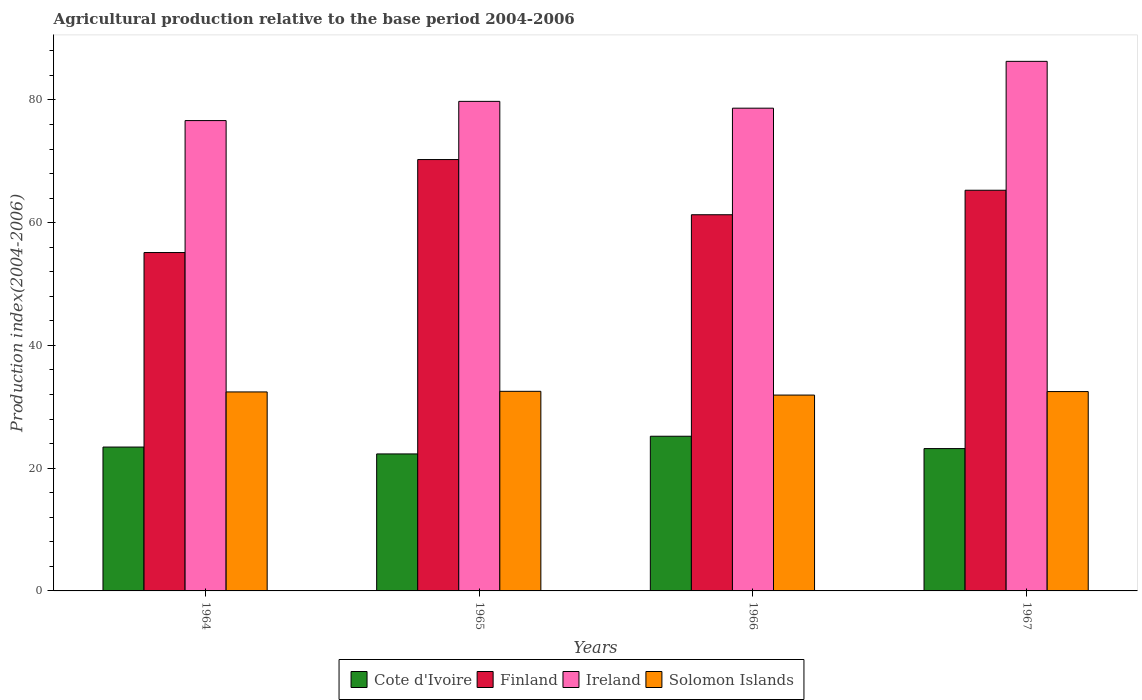How many different coloured bars are there?
Provide a succinct answer. 4. How many groups of bars are there?
Your answer should be very brief. 4. Are the number of bars on each tick of the X-axis equal?
Offer a terse response. Yes. How many bars are there on the 2nd tick from the right?
Your answer should be very brief. 4. What is the label of the 2nd group of bars from the left?
Offer a terse response. 1965. What is the agricultural production index in Ireland in 1964?
Provide a succinct answer. 76.63. Across all years, what is the maximum agricultural production index in Cote d'Ivoire?
Your answer should be very brief. 25.2. Across all years, what is the minimum agricultural production index in Cote d'Ivoire?
Provide a short and direct response. 22.32. In which year was the agricultural production index in Ireland maximum?
Your answer should be compact. 1967. In which year was the agricultural production index in Solomon Islands minimum?
Keep it short and to the point. 1966. What is the total agricultural production index in Solomon Islands in the graph?
Offer a very short reply. 129.33. What is the difference between the agricultural production index in Finland in 1964 and that in 1966?
Your answer should be compact. -6.16. What is the difference between the agricultural production index in Finland in 1964 and the agricultural production index in Solomon Islands in 1967?
Ensure brevity in your answer.  22.65. What is the average agricultural production index in Cote d'Ivoire per year?
Provide a short and direct response. 23.54. In the year 1967, what is the difference between the agricultural production index in Finland and agricultural production index in Solomon Islands?
Keep it short and to the point. 32.8. In how many years, is the agricultural production index in Ireland greater than 48?
Give a very brief answer. 4. What is the ratio of the agricultural production index in Solomon Islands in 1964 to that in 1966?
Provide a short and direct response. 1.02. Is the agricultural production index in Finland in 1965 less than that in 1966?
Provide a succinct answer. No. Is the difference between the agricultural production index in Finland in 1964 and 1965 greater than the difference between the agricultural production index in Solomon Islands in 1964 and 1965?
Provide a short and direct response. No. What is the difference between the highest and the second highest agricultural production index in Solomon Islands?
Offer a very short reply. 0.04. What is the difference between the highest and the lowest agricultural production index in Cote d'Ivoire?
Provide a short and direct response. 2.88. Is the sum of the agricultural production index in Finland in 1965 and 1966 greater than the maximum agricultural production index in Ireland across all years?
Offer a terse response. Yes. What does the 2nd bar from the left in 1967 represents?
Offer a terse response. Finland. What does the 2nd bar from the right in 1965 represents?
Keep it short and to the point. Ireland. Are all the bars in the graph horizontal?
Provide a short and direct response. No. How many years are there in the graph?
Make the answer very short. 4. Does the graph contain any zero values?
Offer a terse response. No. How many legend labels are there?
Your answer should be very brief. 4. How are the legend labels stacked?
Keep it short and to the point. Horizontal. What is the title of the graph?
Your response must be concise. Agricultural production relative to the base period 2004-2006. What is the label or title of the X-axis?
Provide a short and direct response. Years. What is the label or title of the Y-axis?
Provide a short and direct response. Production index(2004-2006). What is the Production index(2004-2006) in Cote d'Ivoire in 1964?
Keep it short and to the point. 23.44. What is the Production index(2004-2006) of Finland in 1964?
Give a very brief answer. 55.13. What is the Production index(2004-2006) of Ireland in 1964?
Your response must be concise. 76.63. What is the Production index(2004-2006) of Solomon Islands in 1964?
Provide a short and direct response. 32.42. What is the Production index(2004-2006) in Cote d'Ivoire in 1965?
Your answer should be very brief. 22.32. What is the Production index(2004-2006) of Finland in 1965?
Your answer should be compact. 70.28. What is the Production index(2004-2006) in Ireland in 1965?
Your answer should be compact. 79.76. What is the Production index(2004-2006) in Solomon Islands in 1965?
Ensure brevity in your answer.  32.52. What is the Production index(2004-2006) of Cote d'Ivoire in 1966?
Ensure brevity in your answer.  25.2. What is the Production index(2004-2006) of Finland in 1966?
Provide a short and direct response. 61.29. What is the Production index(2004-2006) in Ireland in 1966?
Provide a short and direct response. 78.65. What is the Production index(2004-2006) of Solomon Islands in 1966?
Provide a succinct answer. 31.91. What is the Production index(2004-2006) of Cote d'Ivoire in 1967?
Give a very brief answer. 23.19. What is the Production index(2004-2006) of Finland in 1967?
Provide a succinct answer. 65.28. What is the Production index(2004-2006) in Ireland in 1967?
Offer a very short reply. 86.28. What is the Production index(2004-2006) in Solomon Islands in 1967?
Give a very brief answer. 32.48. Across all years, what is the maximum Production index(2004-2006) in Cote d'Ivoire?
Offer a terse response. 25.2. Across all years, what is the maximum Production index(2004-2006) of Finland?
Your response must be concise. 70.28. Across all years, what is the maximum Production index(2004-2006) of Ireland?
Offer a terse response. 86.28. Across all years, what is the maximum Production index(2004-2006) in Solomon Islands?
Keep it short and to the point. 32.52. Across all years, what is the minimum Production index(2004-2006) of Cote d'Ivoire?
Give a very brief answer. 22.32. Across all years, what is the minimum Production index(2004-2006) of Finland?
Offer a terse response. 55.13. Across all years, what is the minimum Production index(2004-2006) of Ireland?
Your response must be concise. 76.63. Across all years, what is the minimum Production index(2004-2006) in Solomon Islands?
Provide a short and direct response. 31.91. What is the total Production index(2004-2006) in Cote d'Ivoire in the graph?
Keep it short and to the point. 94.15. What is the total Production index(2004-2006) of Finland in the graph?
Your answer should be compact. 251.98. What is the total Production index(2004-2006) of Ireland in the graph?
Offer a terse response. 321.32. What is the total Production index(2004-2006) of Solomon Islands in the graph?
Keep it short and to the point. 129.33. What is the difference between the Production index(2004-2006) of Cote d'Ivoire in 1964 and that in 1965?
Offer a very short reply. 1.12. What is the difference between the Production index(2004-2006) in Finland in 1964 and that in 1965?
Your answer should be very brief. -15.15. What is the difference between the Production index(2004-2006) in Ireland in 1964 and that in 1965?
Offer a very short reply. -3.13. What is the difference between the Production index(2004-2006) of Solomon Islands in 1964 and that in 1965?
Ensure brevity in your answer.  -0.1. What is the difference between the Production index(2004-2006) in Cote d'Ivoire in 1964 and that in 1966?
Provide a succinct answer. -1.76. What is the difference between the Production index(2004-2006) of Finland in 1964 and that in 1966?
Make the answer very short. -6.16. What is the difference between the Production index(2004-2006) of Ireland in 1964 and that in 1966?
Provide a succinct answer. -2.02. What is the difference between the Production index(2004-2006) of Solomon Islands in 1964 and that in 1966?
Ensure brevity in your answer.  0.51. What is the difference between the Production index(2004-2006) in Cote d'Ivoire in 1964 and that in 1967?
Your answer should be compact. 0.25. What is the difference between the Production index(2004-2006) of Finland in 1964 and that in 1967?
Offer a very short reply. -10.15. What is the difference between the Production index(2004-2006) in Ireland in 1964 and that in 1967?
Provide a short and direct response. -9.65. What is the difference between the Production index(2004-2006) in Solomon Islands in 1964 and that in 1967?
Keep it short and to the point. -0.06. What is the difference between the Production index(2004-2006) of Cote d'Ivoire in 1965 and that in 1966?
Your response must be concise. -2.88. What is the difference between the Production index(2004-2006) in Finland in 1965 and that in 1966?
Give a very brief answer. 8.99. What is the difference between the Production index(2004-2006) in Ireland in 1965 and that in 1966?
Your answer should be compact. 1.11. What is the difference between the Production index(2004-2006) of Solomon Islands in 1965 and that in 1966?
Your answer should be very brief. 0.61. What is the difference between the Production index(2004-2006) of Cote d'Ivoire in 1965 and that in 1967?
Make the answer very short. -0.87. What is the difference between the Production index(2004-2006) of Finland in 1965 and that in 1967?
Ensure brevity in your answer.  5. What is the difference between the Production index(2004-2006) of Ireland in 1965 and that in 1967?
Provide a succinct answer. -6.52. What is the difference between the Production index(2004-2006) in Solomon Islands in 1965 and that in 1967?
Provide a succinct answer. 0.04. What is the difference between the Production index(2004-2006) of Cote d'Ivoire in 1966 and that in 1967?
Offer a very short reply. 2.01. What is the difference between the Production index(2004-2006) of Finland in 1966 and that in 1967?
Ensure brevity in your answer.  -3.99. What is the difference between the Production index(2004-2006) of Ireland in 1966 and that in 1967?
Offer a terse response. -7.63. What is the difference between the Production index(2004-2006) of Solomon Islands in 1966 and that in 1967?
Ensure brevity in your answer.  -0.57. What is the difference between the Production index(2004-2006) of Cote d'Ivoire in 1964 and the Production index(2004-2006) of Finland in 1965?
Your answer should be very brief. -46.84. What is the difference between the Production index(2004-2006) of Cote d'Ivoire in 1964 and the Production index(2004-2006) of Ireland in 1965?
Provide a succinct answer. -56.32. What is the difference between the Production index(2004-2006) in Cote d'Ivoire in 1964 and the Production index(2004-2006) in Solomon Islands in 1965?
Keep it short and to the point. -9.08. What is the difference between the Production index(2004-2006) of Finland in 1964 and the Production index(2004-2006) of Ireland in 1965?
Offer a very short reply. -24.63. What is the difference between the Production index(2004-2006) of Finland in 1964 and the Production index(2004-2006) of Solomon Islands in 1965?
Your response must be concise. 22.61. What is the difference between the Production index(2004-2006) of Ireland in 1964 and the Production index(2004-2006) of Solomon Islands in 1965?
Make the answer very short. 44.11. What is the difference between the Production index(2004-2006) in Cote d'Ivoire in 1964 and the Production index(2004-2006) in Finland in 1966?
Give a very brief answer. -37.85. What is the difference between the Production index(2004-2006) of Cote d'Ivoire in 1964 and the Production index(2004-2006) of Ireland in 1966?
Give a very brief answer. -55.21. What is the difference between the Production index(2004-2006) in Cote d'Ivoire in 1964 and the Production index(2004-2006) in Solomon Islands in 1966?
Give a very brief answer. -8.47. What is the difference between the Production index(2004-2006) in Finland in 1964 and the Production index(2004-2006) in Ireland in 1966?
Provide a short and direct response. -23.52. What is the difference between the Production index(2004-2006) of Finland in 1964 and the Production index(2004-2006) of Solomon Islands in 1966?
Ensure brevity in your answer.  23.22. What is the difference between the Production index(2004-2006) of Ireland in 1964 and the Production index(2004-2006) of Solomon Islands in 1966?
Make the answer very short. 44.72. What is the difference between the Production index(2004-2006) of Cote d'Ivoire in 1964 and the Production index(2004-2006) of Finland in 1967?
Your answer should be very brief. -41.84. What is the difference between the Production index(2004-2006) of Cote d'Ivoire in 1964 and the Production index(2004-2006) of Ireland in 1967?
Provide a succinct answer. -62.84. What is the difference between the Production index(2004-2006) in Cote d'Ivoire in 1964 and the Production index(2004-2006) in Solomon Islands in 1967?
Offer a very short reply. -9.04. What is the difference between the Production index(2004-2006) of Finland in 1964 and the Production index(2004-2006) of Ireland in 1967?
Offer a very short reply. -31.15. What is the difference between the Production index(2004-2006) in Finland in 1964 and the Production index(2004-2006) in Solomon Islands in 1967?
Offer a terse response. 22.65. What is the difference between the Production index(2004-2006) of Ireland in 1964 and the Production index(2004-2006) of Solomon Islands in 1967?
Your answer should be compact. 44.15. What is the difference between the Production index(2004-2006) of Cote d'Ivoire in 1965 and the Production index(2004-2006) of Finland in 1966?
Provide a succinct answer. -38.97. What is the difference between the Production index(2004-2006) of Cote d'Ivoire in 1965 and the Production index(2004-2006) of Ireland in 1966?
Your answer should be very brief. -56.33. What is the difference between the Production index(2004-2006) of Cote d'Ivoire in 1965 and the Production index(2004-2006) of Solomon Islands in 1966?
Your answer should be compact. -9.59. What is the difference between the Production index(2004-2006) of Finland in 1965 and the Production index(2004-2006) of Ireland in 1966?
Keep it short and to the point. -8.37. What is the difference between the Production index(2004-2006) in Finland in 1965 and the Production index(2004-2006) in Solomon Islands in 1966?
Give a very brief answer. 38.37. What is the difference between the Production index(2004-2006) in Ireland in 1965 and the Production index(2004-2006) in Solomon Islands in 1966?
Provide a short and direct response. 47.85. What is the difference between the Production index(2004-2006) in Cote d'Ivoire in 1965 and the Production index(2004-2006) in Finland in 1967?
Provide a succinct answer. -42.96. What is the difference between the Production index(2004-2006) of Cote d'Ivoire in 1965 and the Production index(2004-2006) of Ireland in 1967?
Your answer should be very brief. -63.96. What is the difference between the Production index(2004-2006) of Cote d'Ivoire in 1965 and the Production index(2004-2006) of Solomon Islands in 1967?
Give a very brief answer. -10.16. What is the difference between the Production index(2004-2006) in Finland in 1965 and the Production index(2004-2006) in Solomon Islands in 1967?
Your response must be concise. 37.8. What is the difference between the Production index(2004-2006) in Ireland in 1965 and the Production index(2004-2006) in Solomon Islands in 1967?
Your response must be concise. 47.28. What is the difference between the Production index(2004-2006) of Cote d'Ivoire in 1966 and the Production index(2004-2006) of Finland in 1967?
Offer a very short reply. -40.08. What is the difference between the Production index(2004-2006) in Cote d'Ivoire in 1966 and the Production index(2004-2006) in Ireland in 1967?
Your answer should be compact. -61.08. What is the difference between the Production index(2004-2006) in Cote d'Ivoire in 1966 and the Production index(2004-2006) in Solomon Islands in 1967?
Provide a short and direct response. -7.28. What is the difference between the Production index(2004-2006) in Finland in 1966 and the Production index(2004-2006) in Ireland in 1967?
Your response must be concise. -24.99. What is the difference between the Production index(2004-2006) of Finland in 1966 and the Production index(2004-2006) of Solomon Islands in 1967?
Ensure brevity in your answer.  28.81. What is the difference between the Production index(2004-2006) of Ireland in 1966 and the Production index(2004-2006) of Solomon Islands in 1967?
Provide a succinct answer. 46.17. What is the average Production index(2004-2006) of Cote d'Ivoire per year?
Provide a succinct answer. 23.54. What is the average Production index(2004-2006) in Finland per year?
Keep it short and to the point. 62.99. What is the average Production index(2004-2006) of Ireland per year?
Make the answer very short. 80.33. What is the average Production index(2004-2006) of Solomon Islands per year?
Your answer should be very brief. 32.33. In the year 1964, what is the difference between the Production index(2004-2006) of Cote d'Ivoire and Production index(2004-2006) of Finland?
Ensure brevity in your answer.  -31.69. In the year 1964, what is the difference between the Production index(2004-2006) in Cote d'Ivoire and Production index(2004-2006) in Ireland?
Keep it short and to the point. -53.19. In the year 1964, what is the difference between the Production index(2004-2006) of Cote d'Ivoire and Production index(2004-2006) of Solomon Islands?
Keep it short and to the point. -8.98. In the year 1964, what is the difference between the Production index(2004-2006) in Finland and Production index(2004-2006) in Ireland?
Your answer should be compact. -21.5. In the year 1964, what is the difference between the Production index(2004-2006) of Finland and Production index(2004-2006) of Solomon Islands?
Keep it short and to the point. 22.71. In the year 1964, what is the difference between the Production index(2004-2006) of Ireland and Production index(2004-2006) of Solomon Islands?
Provide a short and direct response. 44.21. In the year 1965, what is the difference between the Production index(2004-2006) in Cote d'Ivoire and Production index(2004-2006) in Finland?
Your answer should be very brief. -47.96. In the year 1965, what is the difference between the Production index(2004-2006) of Cote d'Ivoire and Production index(2004-2006) of Ireland?
Your answer should be very brief. -57.44. In the year 1965, what is the difference between the Production index(2004-2006) of Finland and Production index(2004-2006) of Ireland?
Your answer should be very brief. -9.48. In the year 1965, what is the difference between the Production index(2004-2006) of Finland and Production index(2004-2006) of Solomon Islands?
Make the answer very short. 37.76. In the year 1965, what is the difference between the Production index(2004-2006) of Ireland and Production index(2004-2006) of Solomon Islands?
Provide a succinct answer. 47.24. In the year 1966, what is the difference between the Production index(2004-2006) in Cote d'Ivoire and Production index(2004-2006) in Finland?
Offer a very short reply. -36.09. In the year 1966, what is the difference between the Production index(2004-2006) in Cote d'Ivoire and Production index(2004-2006) in Ireland?
Your answer should be compact. -53.45. In the year 1966, what is the difference between the Production index(2004-2006) in Cote d'Ivoire and Production index(2004-2006) in Solomon Islands?
Make the answer very short. -6.71. In the year 1966, what is the difference between the Production index(2004-2006) of Finland and Production index(2004-2006) of Ireland?
Offer a very short reply. -17.36. In the year 1966, what is the difference between the Production index(2004-2006) in Finland and Production index(2004-2006) in Solomon Islands?
Ensure brevity in your answer.  29.38. In the year 1966, what is the difference between the Production index(2004-2006) in Ireland and Production index(2004-2006) in Solomon Islands?
Your response must be concise. 46.74. In the year 1967, what is the difference between the Production index(2004-2006) in Cote d'Ivoire and Production index(2004-2006) in Finland?
Keep it short and to the point. -42.09. In the year 1967, what is the difference between the Production index(2004-2006) in Cote d'Ivoire and Production index(2004-2006) in Ireland?
Your response must be concise. -63.09. In the year 1967, what is the difference between the Production index(2004-2006) of Cote d'Ivoire and Production index(2004-2006) of Solomon Islands?
Your answer should be compact. -9.29. In the year 1967, what is the difference between the Production index(2004-2006) of Finland and Production index(2004-2006) of Solomon Islands?
Provide a succinct answer. 32.8. In the year 1967, what is the difference between the Production index(2004-2006) in Ireland and Production index(2004-2006) in Solomon Islands?
Provide a short and direct response. 53.8. What is the ratio of the Production index(2004-2006) of Cote d'Ivoire in 1964 to that in 1965?
Provide a succinct answer. 1.05. What is the ratio of the Production index(2004-2006) of Finland in 1964 to that in 1965?
Provide a succinct answer. 0.78. What is the ratio of the Production index(2004-2006) in Ireland in 1964 to that in 1965?
Offer a very short reply. 0.96. What is the ratio of the Production index(2004-2006) in Cote d'Ivoire in 1964 to that in 1966?
Provide a succinct answer. 0.93. What is the ratio of the Production index(2004-2006) of Finland in 1964 to that in 1966?
Your answer should be very brief. 0.9. What is the ratio of the Production index(2004-2006) of Ireland in 1964 to that in 1966?
Your response must be concise. 0.97. What is the ratio of the Production index(2004-2006) of Solomon Islands in 1964 to that in 1966?
Keep it short and to the point. 1.02. What is the ratio of the Production index(2004-2006) in Cote d'Ivoire in 1964 to that in 1967?
Your answer should be very brief. 1.01. What is the ratio of the Production index(2004-2006) in Finland in 1964 to that in 1967?
Provide a short and direct response. 0.84. What is the ratio of the Production index(2004-2006) in Ireland in 1964 to that in 1967?
Offer a terse response. 0.89. What is the ratio of the Production index(2004-2006) of Cote d'Ivoire in 1965 to that in 1966?
Your response must be concise. 0.89. What is the ratio of the Production index(2004-2006) of Finland in 1965 to that in 1966?
Offer a very short reply. 1.15. What is the ratio of the Production index(2004-2006) of Ireland in 1965 to that in 1966?
Offer a terse response. 1.01. What is the ratio of the Production index(2004-2006) of Solomon Islands in 1965 to that in 1966?
Offer a terse response. 1.02. What is the ratio of the Production index(2004-2006) in Cote d'Ivoire in 1965 to that in 1967?
Provide a succinct answer. 0.96. What is the ratio of the Production index(2004-2006) of Finland in 1965 to that in 1967?
Provide a succinct answer. 1.08. What is the ratio of the Production index(2004-2006) in Ireland in 1965 to that in 1967?
Make the answer very short. 0.92. What is the ratio of the Production index(2004-2006) in Cote d'Ivoire in 1966 to that in 1967?
Offer a terse response. 1.09. What is the ratio of the Production index(2004-2006) in Finland in 1966 to that in 1967?
Keep it short and to the point. 0.94. What is the ratio of the Production index(2004-2006) in Ireland in 1966 to that in 1967?
Your response must be concise. 0.91. What is the ratio of the Production index(2004-2006) of Solomon Islands in 1966 to that in 1967?
Provide a short and direct response. 0.98. What is the difference between the highest and the second highest Production index(2004-2006) in Cote d'Ivoire?
Give a very brief answer. 1.76. What is the difference between the highest and the second highest Production index(2004-2006) of Finland?
Offer a very short reply. 5. What is the difference between the highest and the second highest Production index(2004-2006) of Ireland?
Provide a short and direct response. 6.52. What is the difference between the highest and the lowest Production index(2004-2006) of Cote d'Ivoire?
Make the answer very short. 2.88. What is the difference between the highest and the lowest Production index(2004-2006) in Finland?
Your answer should be very brief. 15.15. What is the difference between the highest and the lowest Production index(2004-2006) in Ireland?
Give a very brief answer. 9.65. What is the difference between the highest and the lowest Production index(2004-2006) of Solomon Islands?
Give a very brief answer. 0.61. 